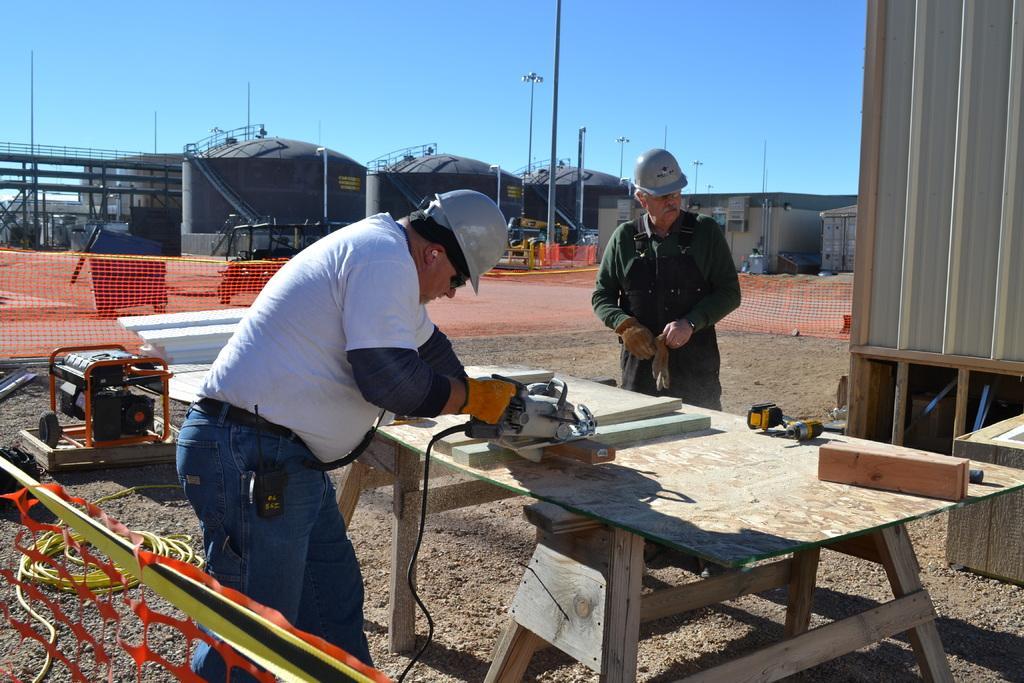Could you give a brief overview of what you see in this image? In this picture there is a man working on a wood with the machine, wearing helmet and spectacles. In front of him there is another man here. In the background there is a factory. we can observe a fence here. There is a sky here. 